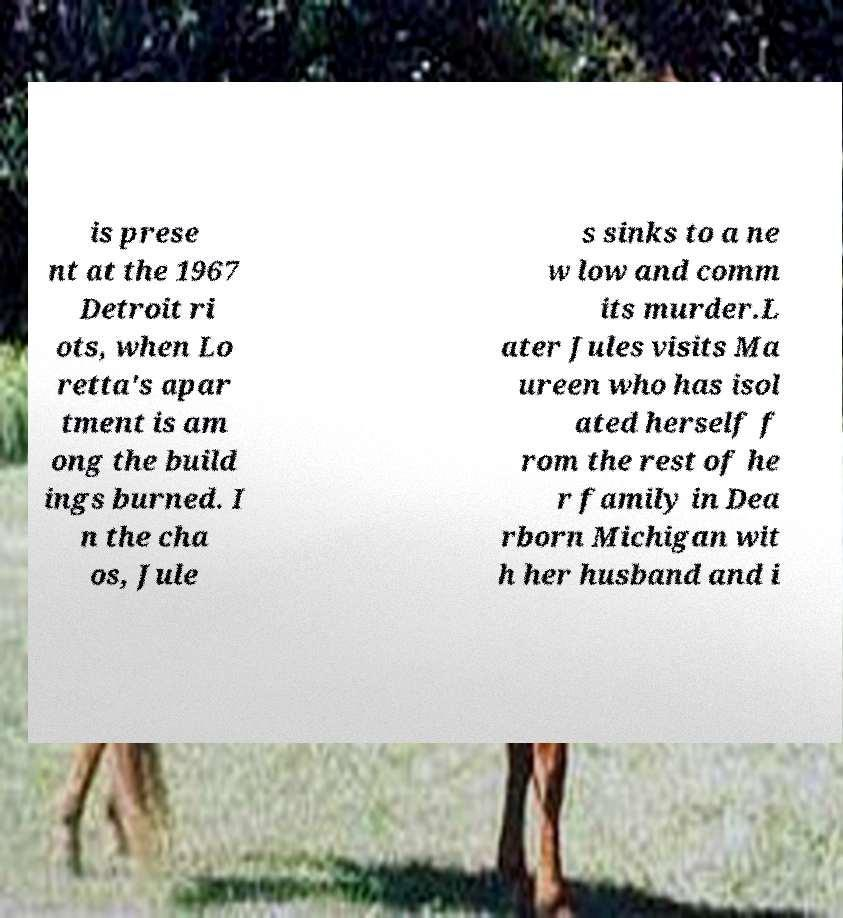Could you assist in decoding the text presented in this image and type it out clearly? is prese nt at the 1967 Detroit ri ots, when Lo retta's apar tment is am ong the build ings burned. I n the cha os, Jule s sinks to a ne w low and comm its murder.L ater Jules visits Ma ureen who has isol ated herself f rom the rest of he r family in Dea rborn Michigan wit h her husband and i 